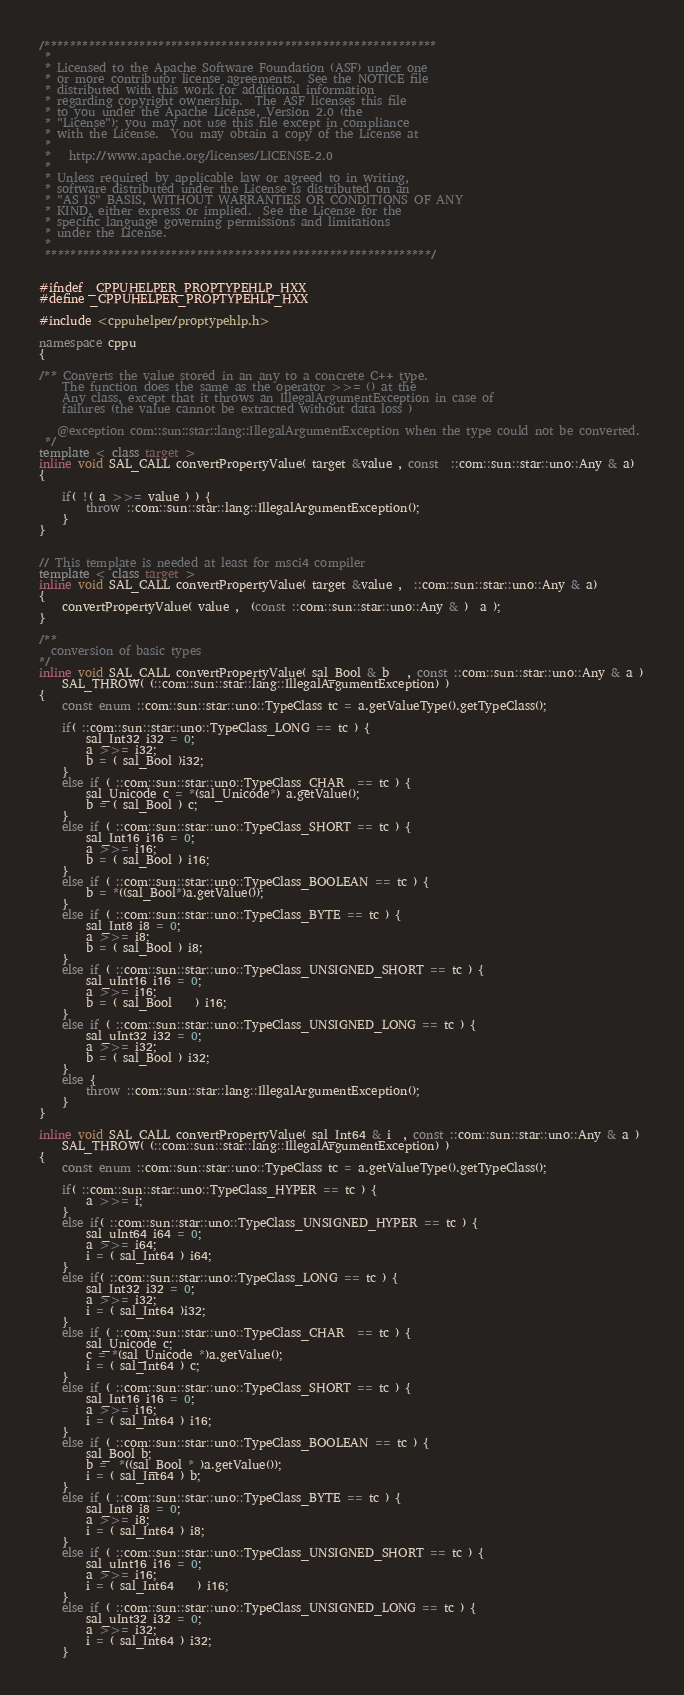Convert code to text. <code><loc_0><loc_0><loc_500><loc_500><_C++_>/**************************************************************
 * 
 * Licensed to the Apache Software Foundation (ASF) under one
 * or more contributor license agreements.  See the NOTICE file
 * distributed with this work for additional information
 * regarding copyright ownership.  The ASF licenses this file
 * to you under the Apache License, Version 2.0 (the
 * "License"); you may not use this file except in compliance
 * with the License.  You may obtain a copy of the License at
 * 
 *   http://www.apache.org/licenses/LICENSE-2.0
 * 
 * Unless required by applicable law or agreed to in writing,
 * software distributed under the License is distributed on an
 * "AS IS" BASIS, WITHOUT WARRANTIES OR CONDITIONS OF ANY
 * KIND, either express or implied.  See the License for the
 * specific language governing permissions and limitations
 * under the License.
 * 
 *************************************************************/


#ifndef _CPPUHELPER_PROPTYPEHLP_HXX
#define _CPPUHELPER_PROPTYPEHLP_HXX

#include <cppuhelper/proptypehlp.h>

namespace cppu
{     

/** Converts the value stored in an any to a concrete C++ type.
    The function does the same as the operator >>= () at the
    Any class, except that it throws an IllegalArgumentException in case of
    failures (the value cannot be extracted without data loss )
   
   @exception com::sun::star::lang::IllegalArgumentException when the type could not be converted.
 */
template < class target >
inline void SAL_CALL convertPropertyValue( target &value , const  ::com::sun::star::uno::Any & a)
{

	if( !( a >>= value ) ) {
		throw ::com::sun::star::lang::IllegalArgumentException();	
	}
}


// This template is needed at least for msci4 compiler
template < class target >
inline void SAL_CALL convertPropertyValue( target &value ,  ::com::sun::star::uno::Any & a)
{
	convertPropertyValue( value ,  (const ::com::sun::star::uno::Any & )  a );
}

/**
  conversion of basic types
*/
inline void SAL_CALL convertPropertyValue( sal_Bool & b   , const ::com::sun::star::uno::Any & a )
	SAL_THROW( (::com::sun::star::lang::IllegalArgumentException) )
{
	const enum ::com::sun::star::uno::TypeClass tc = a.getValueType().getTypeClass();

	if( ::com::sun::star::uno::TypeClass_LONG == tc ) {
		sal_Int32 i32 = 0;
		a >>= i32;
		b = ( sal_Bool )i32;
	}
	else if ( ::com::sun::star::uno::TypeClass_CHAR  == tc ) {
		sal_Unicode c = *(sal_Unicode*) a.getValue();
		b = ( sal_Bool ) c;	
	}
	else if ( ::com::sun::star::uno::TypeClass_SHORT == tc ) {
		sal_Int16 i16 = 0;
		a >>= i16;
		b = ( sal_Bool ) i16;	
	}
	else if ( ::com::sun::star::uno::TypeClass_BOOLEAN == tc ) {
		b = *((sal_Bool*)a.getValue());
	}
	else if ( ::com::sun::star::uno::TypeClass_BYTE == tc ) {
		sal_Int8 i8 = 0;
		a >>= i8;
		b = ( sal_Bool ) i8;	
	}
	else if ( ::com::sun::star::uno::TypeClass_UNSIGNED_SHORT == tc ) {
		sal_uInt16 i16 = 0;
		a >>= i16;
		b = ( sal_Bool	) i16;
	}
	else if ( ::com::sun::star::uno::TypeClass_UNSIGNED_LONG == tc ) {
		sal_uInt32 i32 = 0;
		a >>= i32;
		b = ( sal_Bool ) i32;
	}
	else {
		throw ::com::sun::star::lang::IllegalArgumentException();	
	}		
}

inline void SAL_CALL convertPropertyValue( sal_Int64 & i  , const ::com::sun::star::uno::Any & a ) 
	SAL_THROW( (::com::sun::star::lang::IllegalArgumentException) )
{
	const enum ::com::sun::star::uno::TypeClass tc = a.getValueType().getTypeClass();
	
	if( ::com::sun::star::uno::TypeClass_HYPER == tc ) {
		a >>= i;	
	}
	else if( ::com::sun::star::uno::TypeClass_UNSIGNED_HYPER == tc ) {
		sal_uInt64 i64 = 0;
		a >>= i64;
		i = ( sal_Int64 ) i64;
	}
	else if( ::com::sun::star::uno::TypeClass_LONG == tc ) {
		sal_Int32 i32 = 0;
		a >>= i32;
		i = ( sal_Int64 )i32;
	}
	else if ( ::com::sun::star::uno::TypeClass_CHAR  == tc ) {
		sal_Unicode c;
		c = *(sal_Unicode *)a.getValue();
		i = ( sal_Int64 ) c;	
	}
	else if ( ::com::sun::star::uno::TypeClass_SHORT == tc ) {
		sal_Int16 i16 = 0;
		a >>= i16;
		i = ( sal_Int64 ) i16;	
	}
	else if ( ::com::sun::star::uno::TypeClass_BOOLEAN == tc ) {
		sal_Bool b;
		b =  *((sal_Bool * )a.getValue());
		i = ( sal_Int64 ) b;	
	}
	else if ( ::com::sun::star::uno::TypeClass_BYTE == tc ) {
		sal_Int8 i8 = 0;
		a >>= i8;
		i = ( sal_Int64 ) i8;	
	}
	else if ( ::com::sun::star::uno::TypeClass_UNSIGNED_SHORT == tc ) {
		sal_uInt16 i16 = 0;
		a >>= i16;
		i = ( sal_Int64	) i16;
	}
	else if ( ::com::sun::star::uno::TypeClass_UNSIGNED_LONG == tc ) {
		sal_uInt32 i32 = 0;
		a >>= i32;
		i = ( sal_Int64 ) i32;
	}</code> 